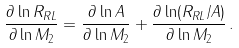<formula> <loc_0><loc_0><loc_500><loc_500>\frac { \partial \ln R _ { R L } } { \partial \ln M _ { 2 } } = \frac { \partial \ln A } { \partial \ln M _ { 2 } } + \frac { \partial \ln ( R _ { R L } / A ) } { \partial \ln M _ { 2 } } \, .</formula> 